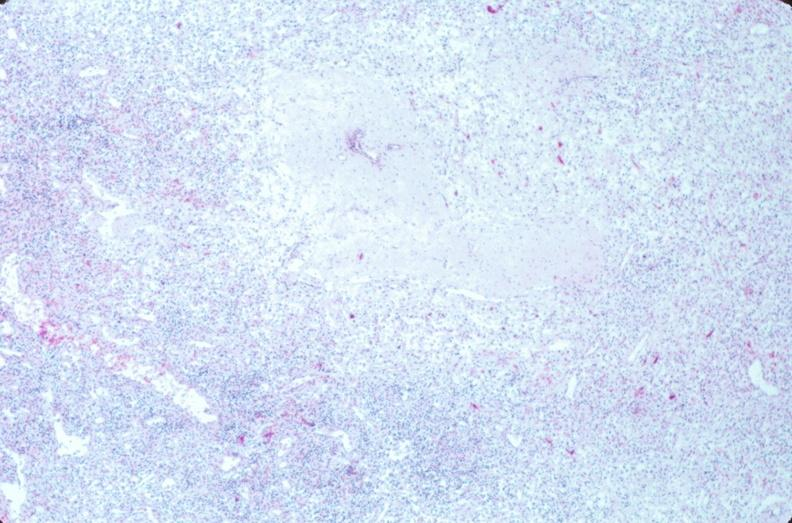does this image show lymph nodes, nodular sclerosing hodgkins disease?
Answer the question using a single word or phrase. Yes 